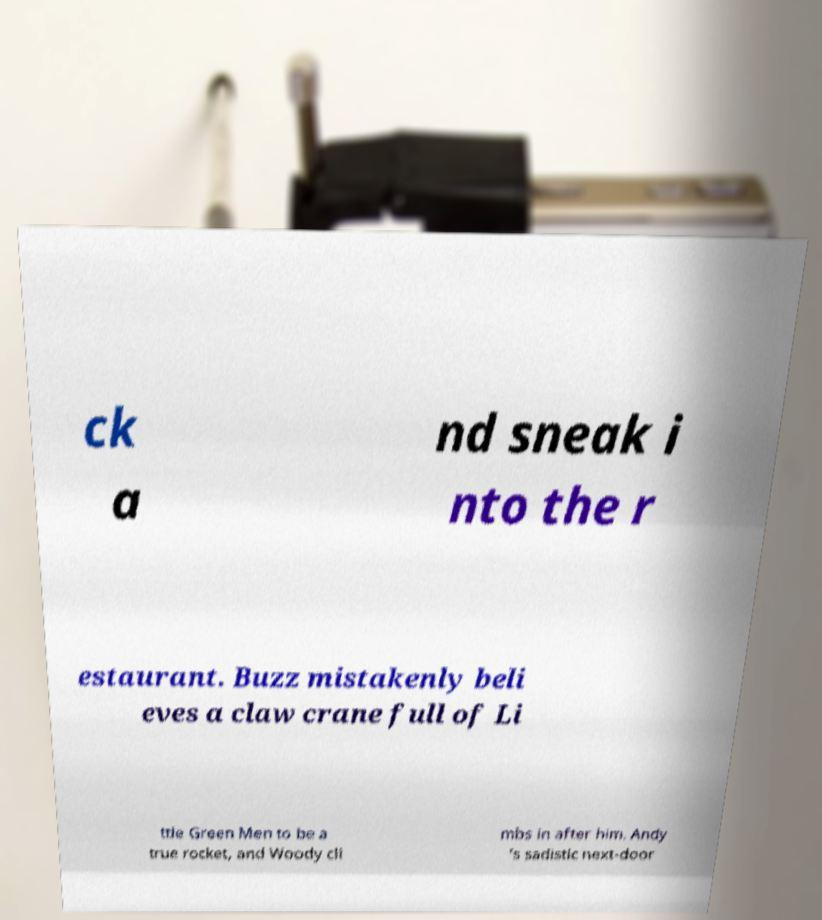I need the written content from this picture converted into text. Can you do that? ck a nd sneak i nto the r estaurant. Buzz mistakenly beli eves a claw crane full of Li ttle Green Men to be a true rocket, and Woody cli mbs in after him. Andy 's sadistic next-door 